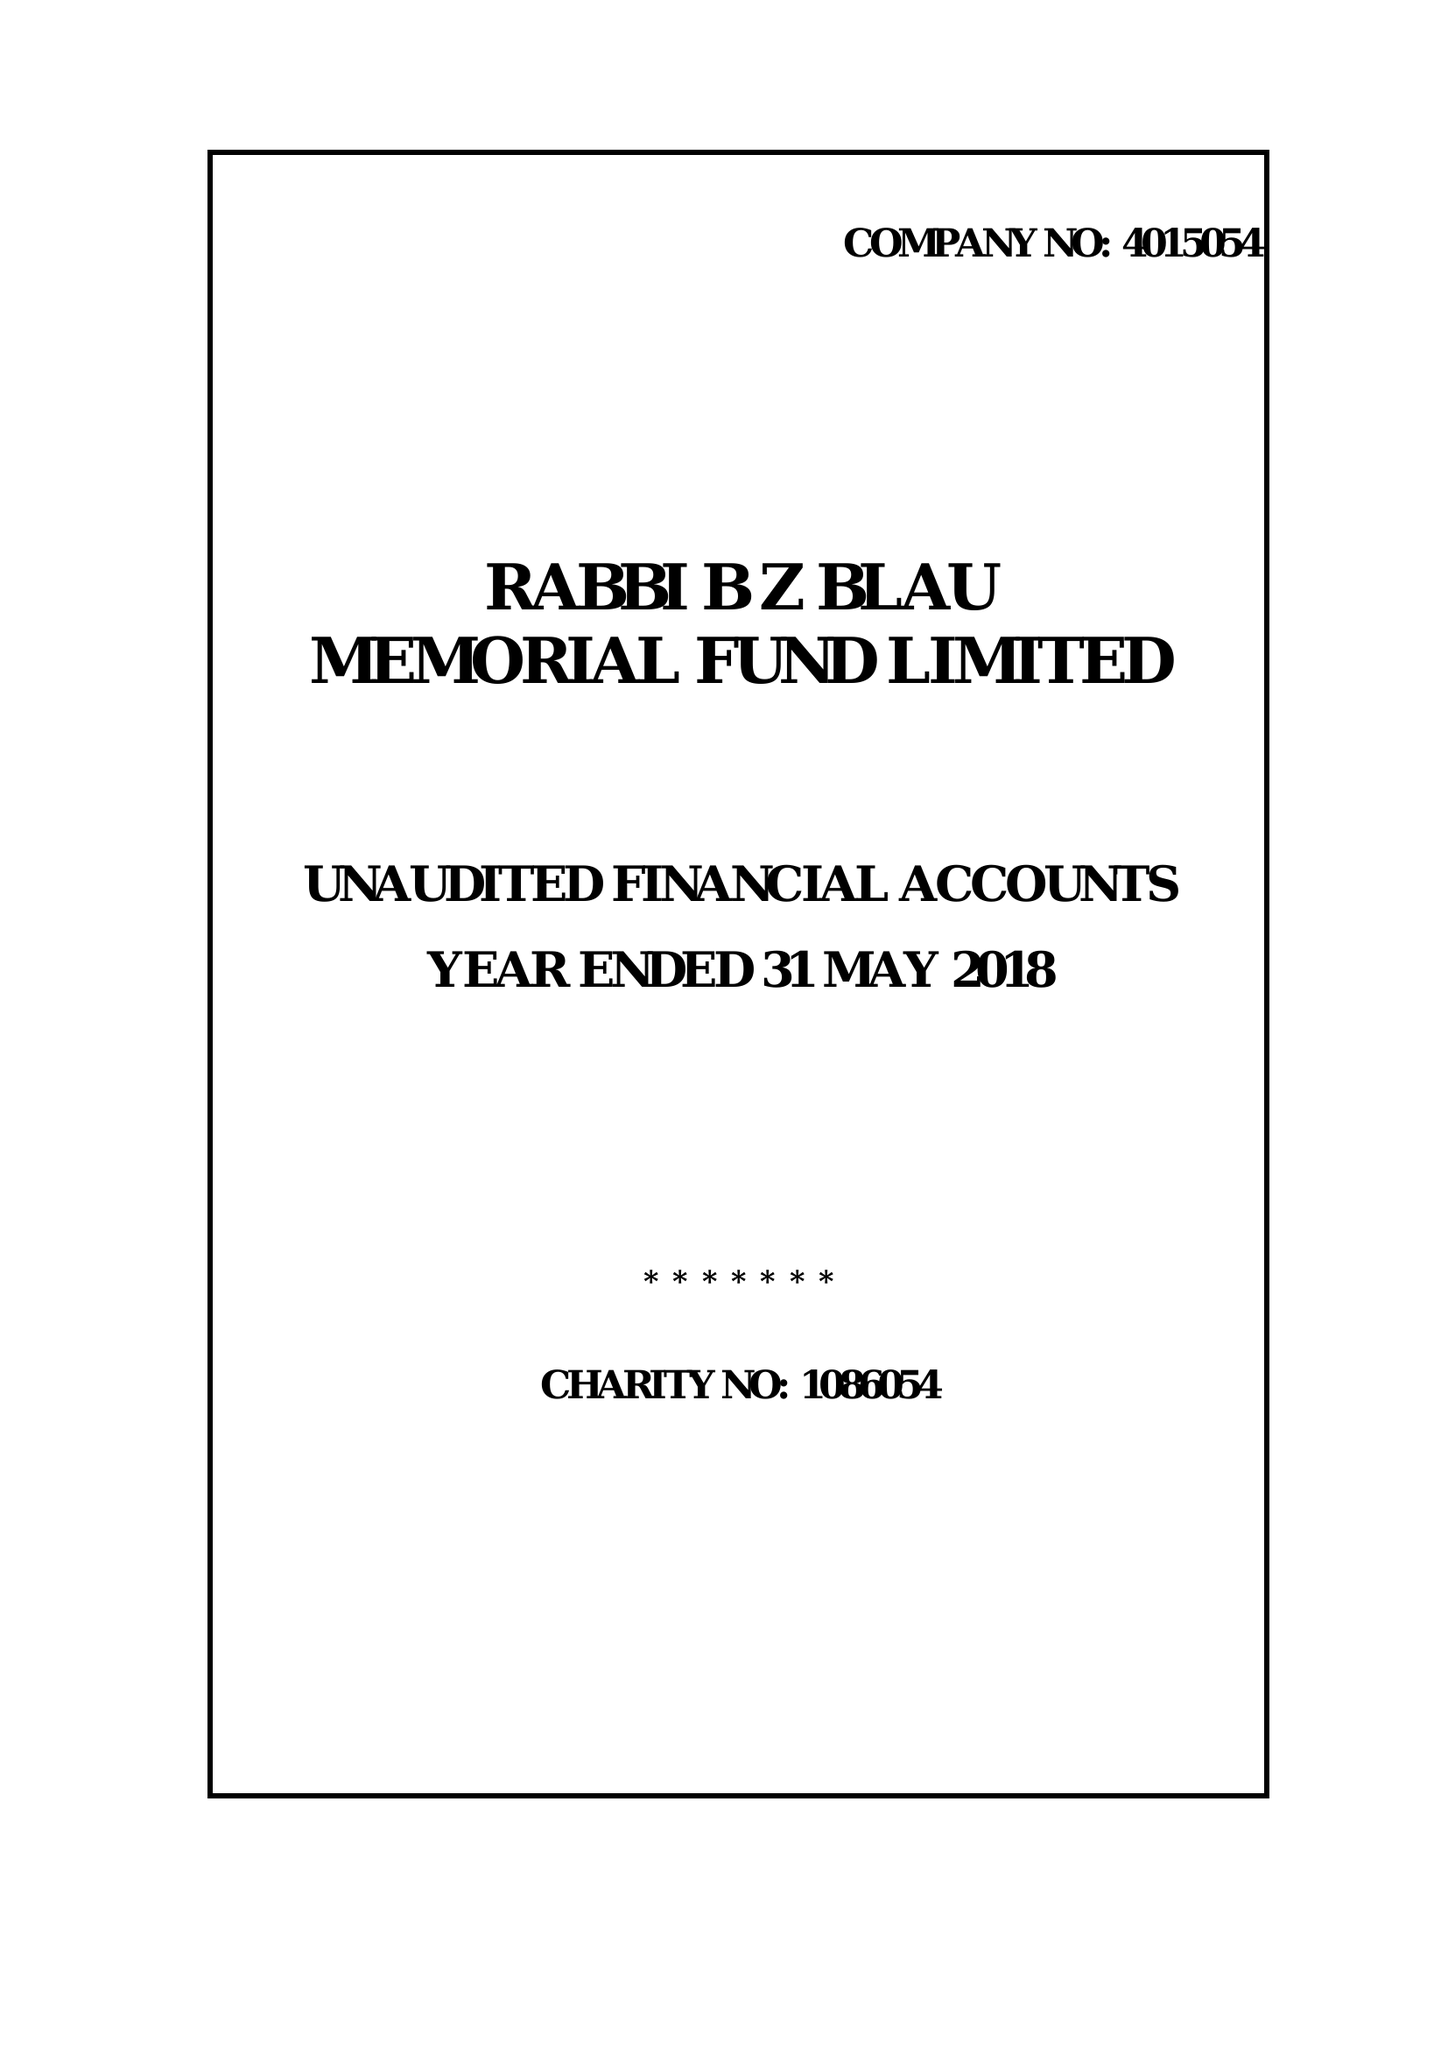What is the value for the address__post_town?
Answer the question using a single word or phrase. LONDON 